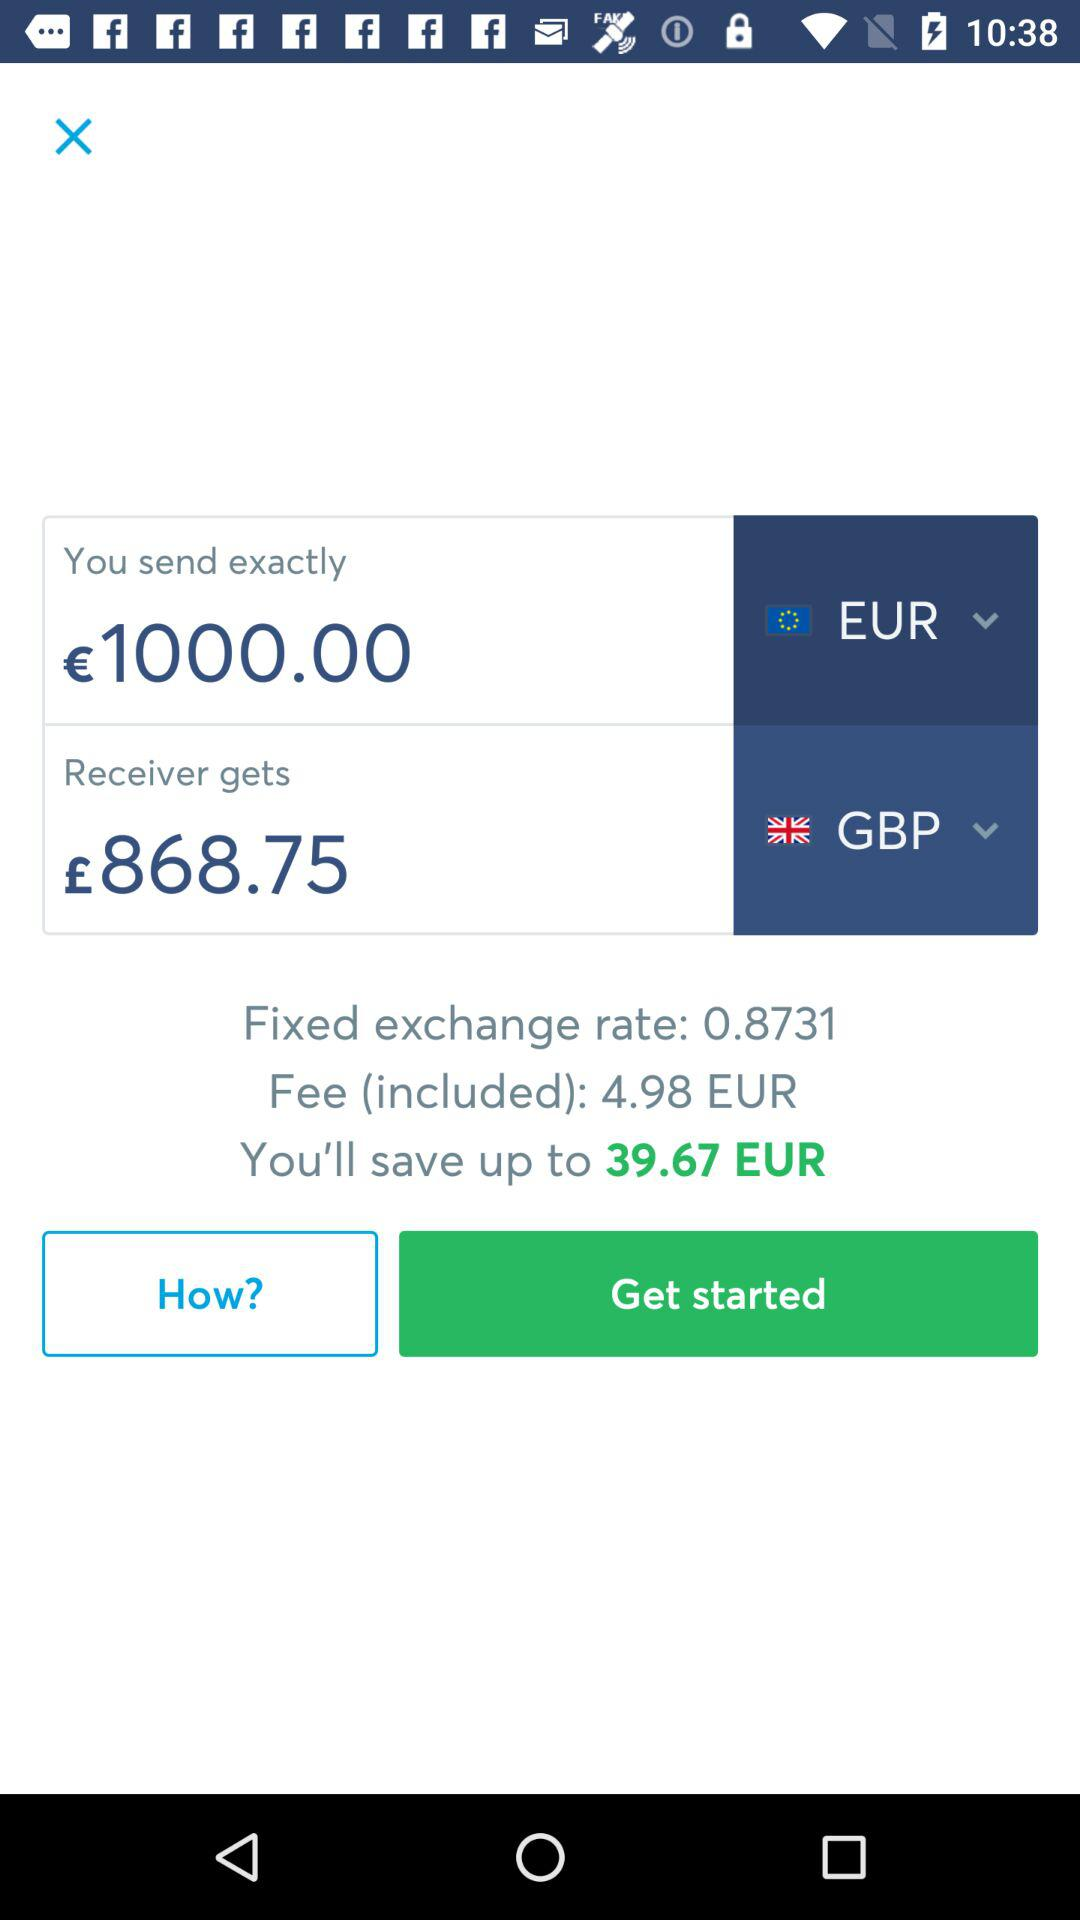How much money does the receiver get? The receiver gets £868.75. 